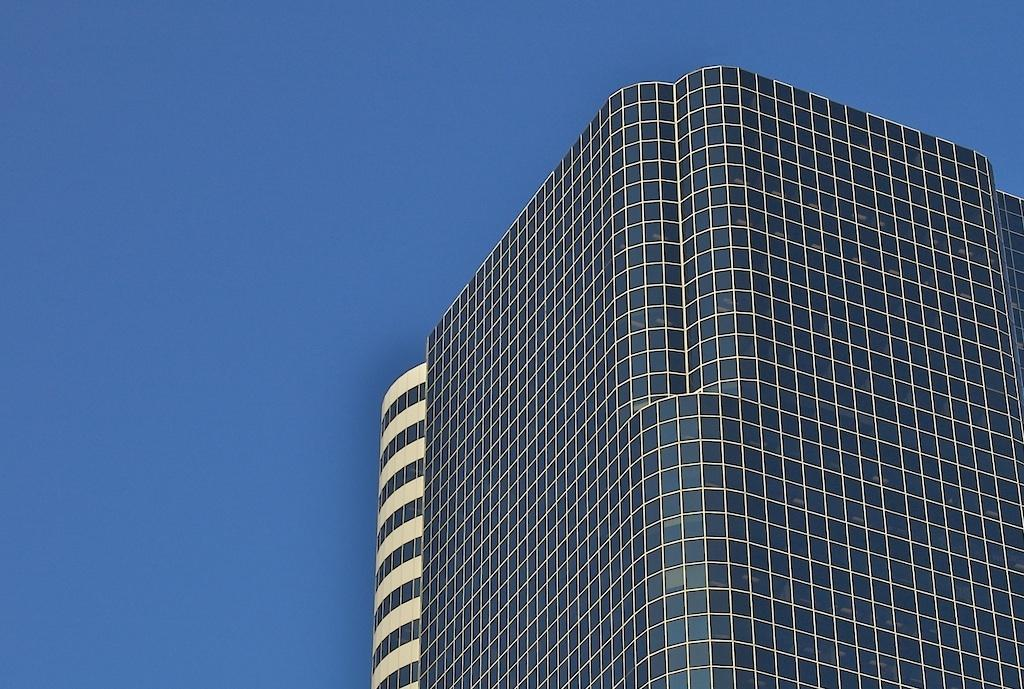What type of buildings can be seen on the right side of the image? There are buildings with glass windows on the right side of the image. What can be seen in the background of the image? The background of the image includes a blue sky. Can you see any ghosts in the image? There are no ghosts present in the image. How does the duck look in the image? There is no duck present in the image. 